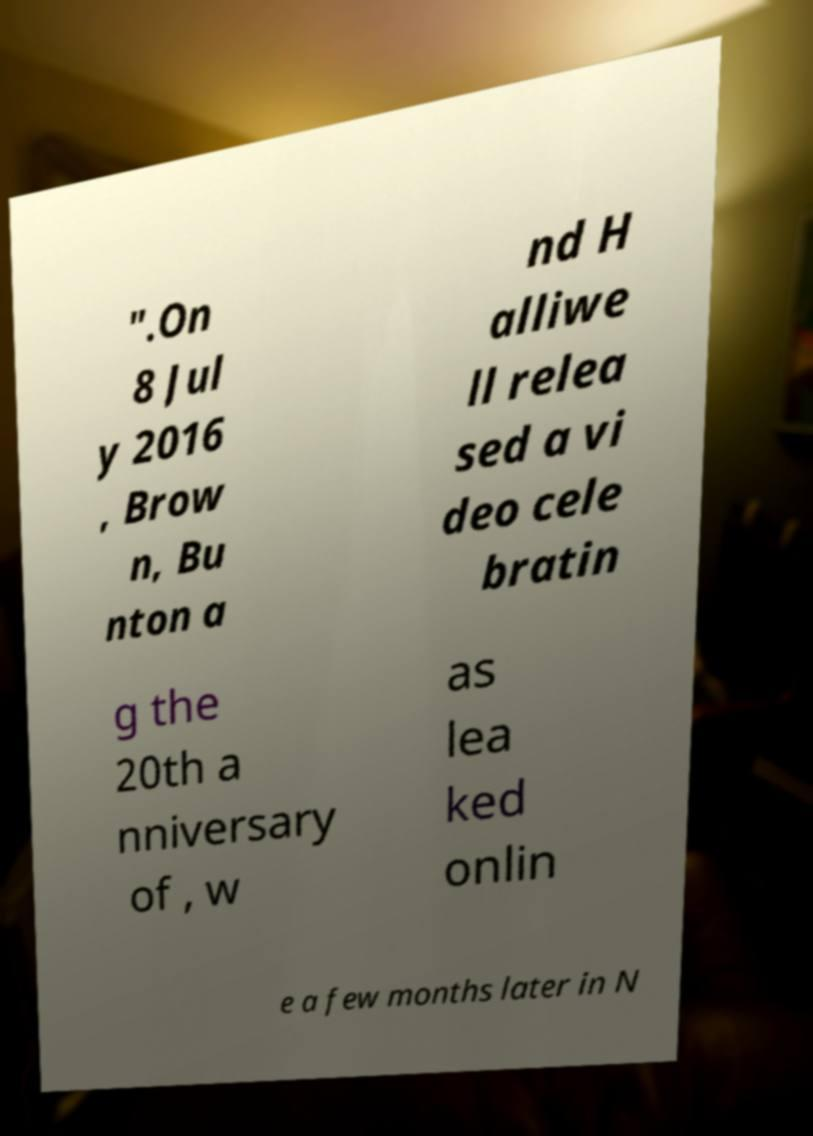There's text embedded in this image that I need extracted. Can you transcribe it verbatim? ".On 8 Jul y 2016 , Brow n, Bu nton a nd H alliwe ll relea sed a vi deo cele bratin g the 20th a nniversary of , w as lea ked onlin e a few months later in N 